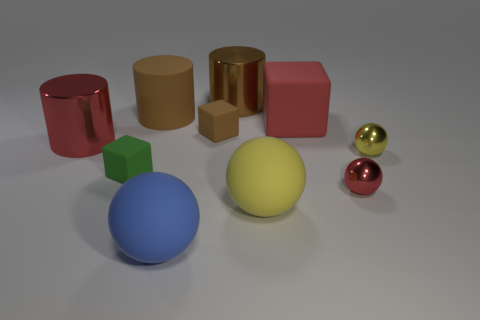Subtract all spheres. How many objects are left? 6 Add 9 blue objects. How many blue objects are left? 10 Add 7 big red shiny cylinders. How many big red shiny cylinders exist? 8 Subtract 2 brown cylinders. How many objects are left? 8 Subtract all tiny red metal things. Subtract all large red matte spheres. How many objects are left? 9 